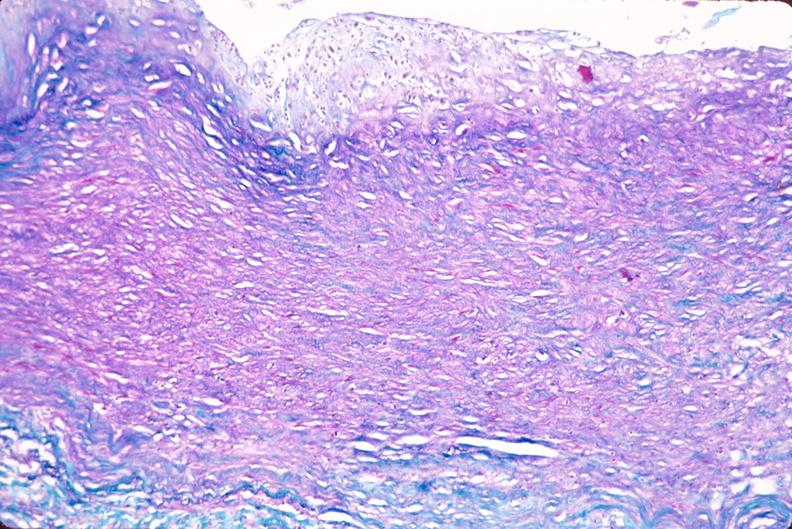where is this in?
Answer the question using a single word or phrase. In vasculature 